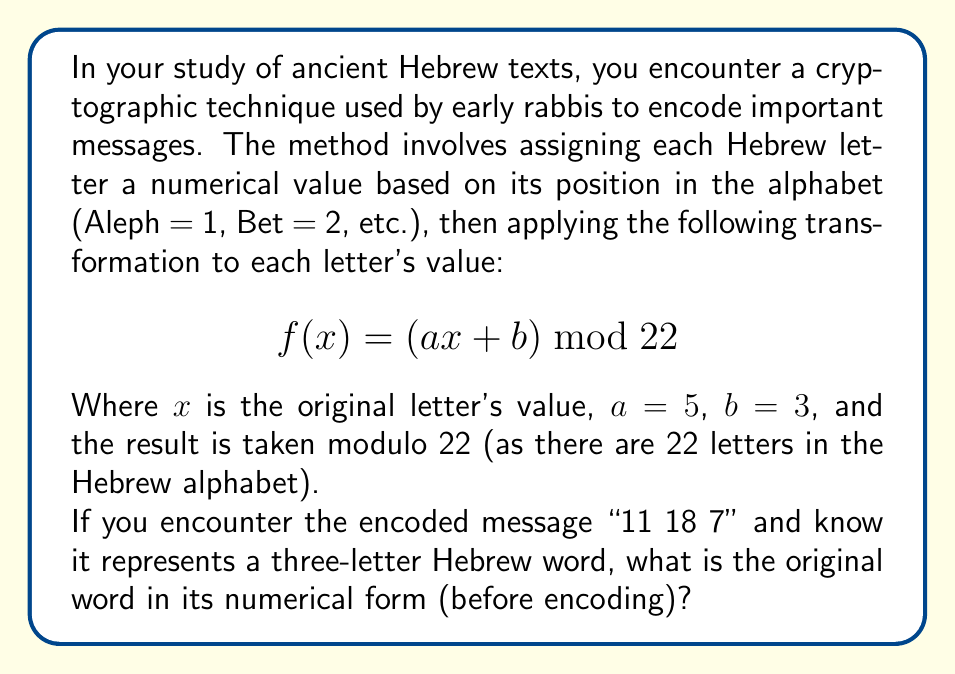What is the answer to this math problem? To solve this problem, we need to reverse the encoding process. Let's approach this step-by-step:

1) The encoding function is $f(x) = (5x + 3) \bmod 22$

2) To decode, we need the inverse function. In modular arithmetic, this is:

   $$f^{-1}(y) = (a^{-1}(y - b)) \bmod 22$$

   where $a^{-1}$ is the modular multiplicative inverse of $a$ in mod 22.

3) To find $5^{-1} \bmod 22$, we can use the extended Euclidean algorithm or simply try values:
   $5 \cdot 9 = 45 \equiv 1 \pmod{22}$
   So, $5^{-1} \equiv 9 \pmod{22}$

4) Our decoding function is thus:
   $$f^{-1}(y) = (9(y - 3)) \bmod 22$$

5) Now, let's apply this to each number in the encoded message:

   For 11: $f^{-1}(11) = (9(11 - 3)) \bmod 22 = (9 \cdot 8) \bmod 22 = 72 \bmod 22 = 6$
   
   For 18: $f^{-1}(18) = (9(18 - 3)) \bmod 22 = (9 \cdot 15) \bmod 22 = 135 \bmod 22 = 3$
   
   For 7:  $f^{-1}(7) = (9(7 - 3)) \bmod 22 = (9 \cdot 4) \bmod 22 = 36 \bmod 22 = 14$

6) Therefore, the original word in its numerical form is 6 3 14.
Answer: 6 3 14 